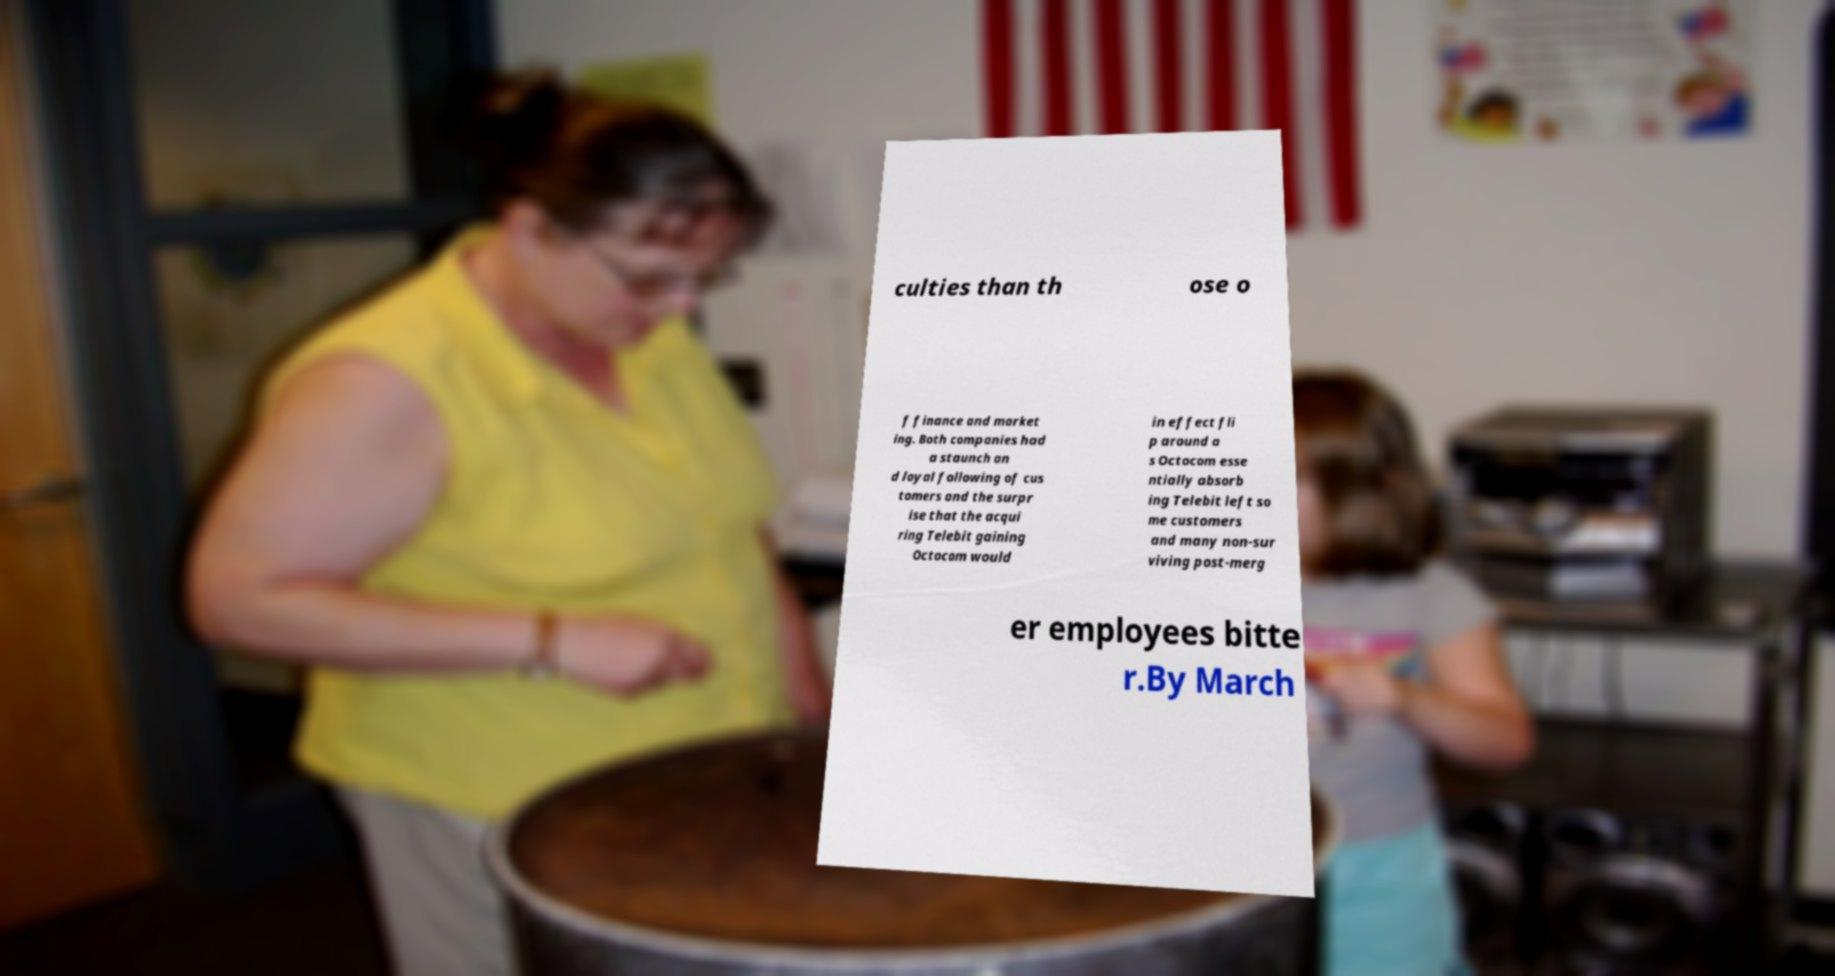There's text embedded in this image that I need extracted. Can you transcribe it verbatim? culties than th ose o f finance and market ing. Both companies had a staunch an d loyal following of cus tomers and the surpr ise that the acqui ring Telebit gaining Octocom would in effect fli p around a s Octocom esse ntially absorb ing Telebit left so me customers and many non-sur viving post-merg er employees bitte r.By March 